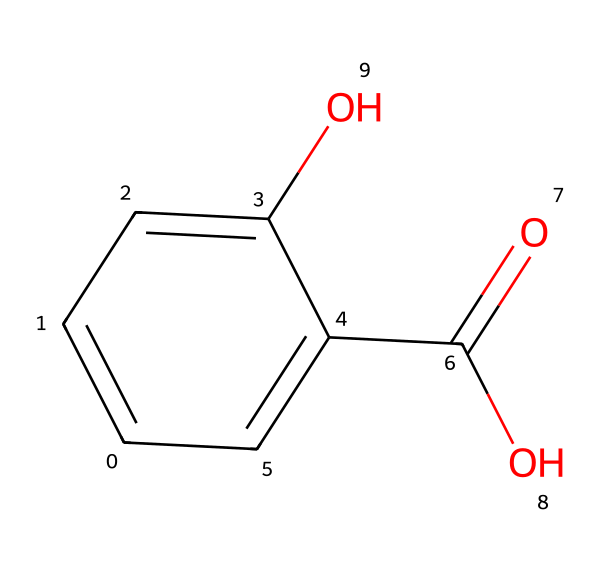What is the chemical name of this compound? This compound's SMILES indicates that it contains a hydroxyl group (-OH) on a benzene ring with a carboxylic acid (-COOH) group attached. The combination of these features points to salicylic acid.
Answer: salicylic acid How many carbon atoms are in salicylic acid? Examining the SMILES, we can count the number of carbon atoms present. The structure shows a total of seven carbon atoms in the main structure.
Answer: seven What functional groups are present in salicylic acid? From the structure discerned from the SMILES, salicylic acid has two main functional groups: a hydroxyl group (-OH) and a carboxylic acid group (-COOH).
Answer: hydroxyl and carboxylic acid How many hydroxyl groups are in salicylic acid? The SMILES reveals one hydroxyl group (-OH) directly attached to the benzene ring.
Answer: one Is salicylic acid a weak acid, strong acid, or different? The presence of the carboxylic acid functional group (-COOH) implies acidity but it's a weak acid due to its partial ionization in solution.
Answer: weak acid How does the presence of the hydroxyl group affect the solubility of salicylic acid? The hydroxyl group provides polarity, which enhances solubility in water due to hydrogen bonding with water molecules.
Answer: increases solubility What type of compound is salicylic acid classified as? Given that salicylic acid contains a phenolic structure along with a carboxylic acid, it is classified as a phenolic compound or phenol.
Answer: phenolic compound 